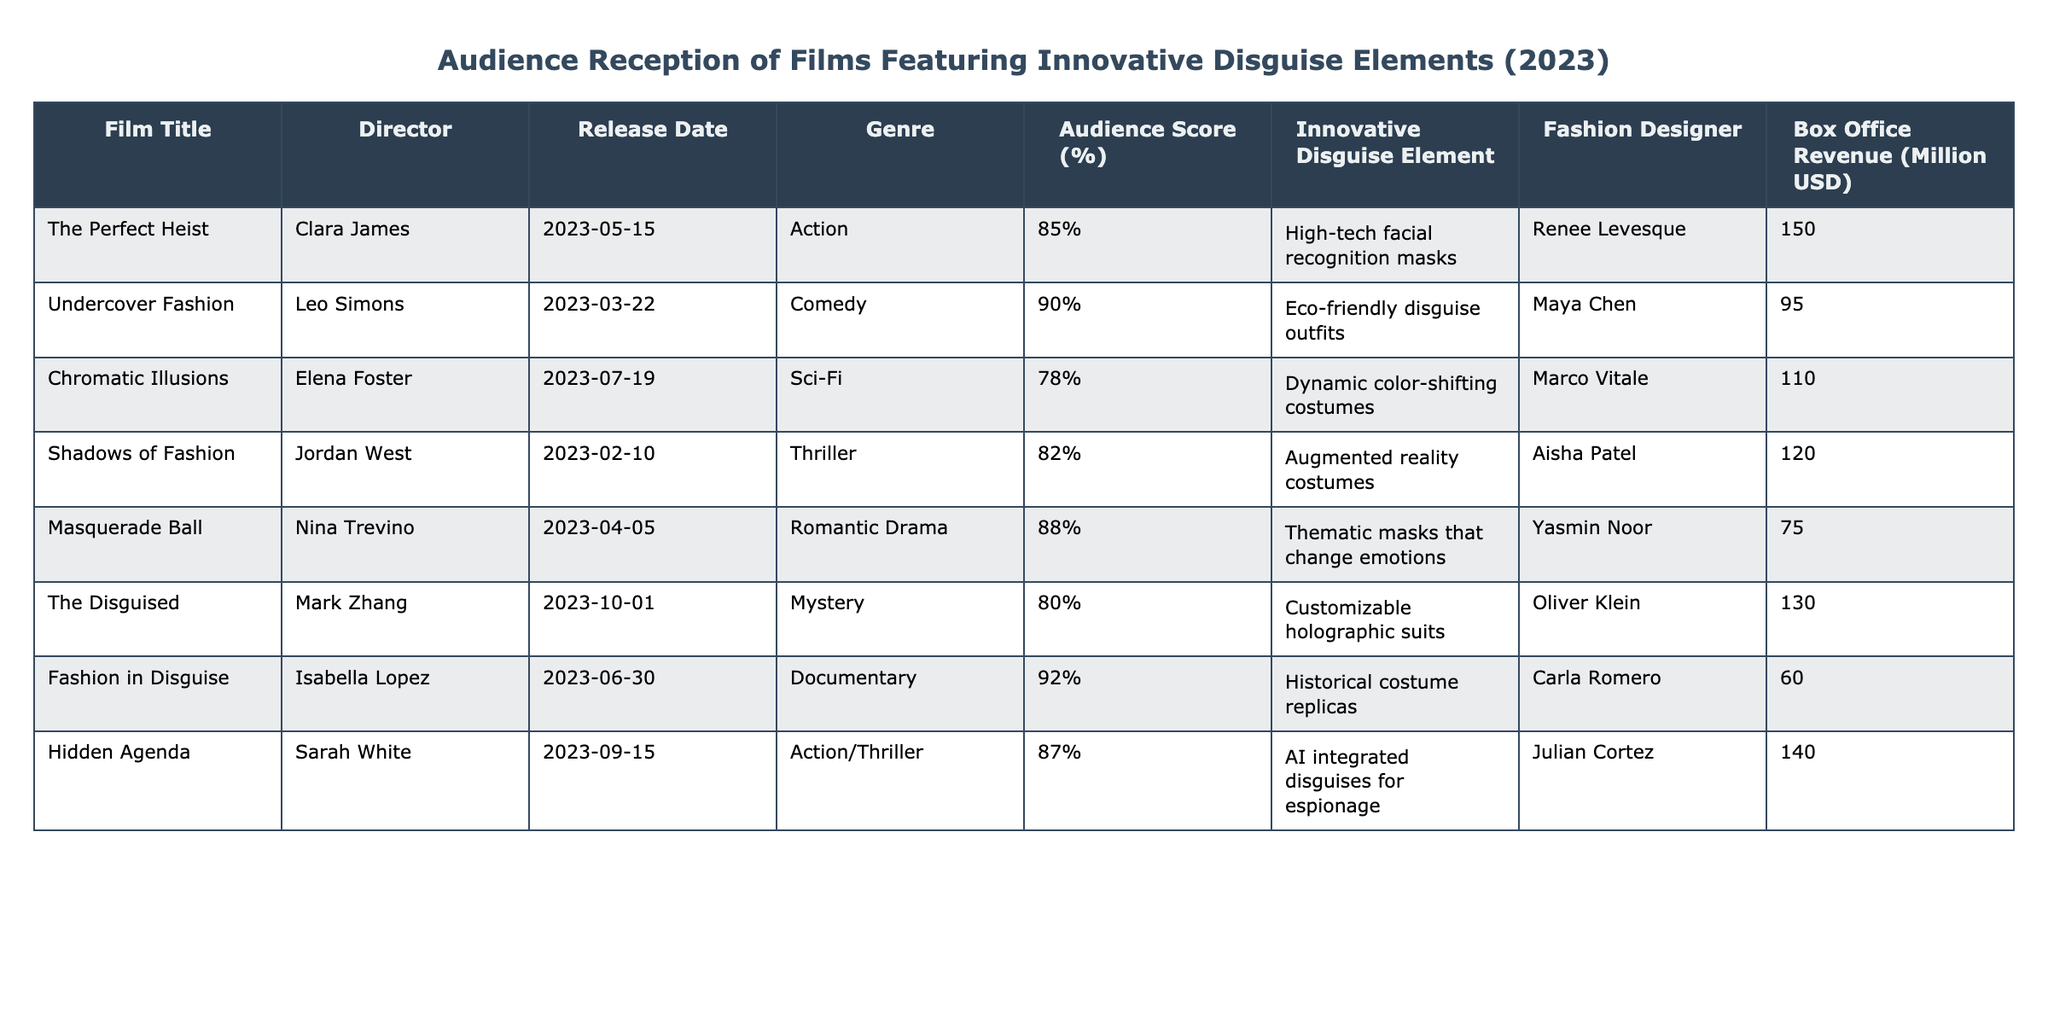What is the highest audience score percentage among the films listed? By looking at the "Audience Score (%)" column, I check for the maximum value, which is 92% from "Fashion in Disguise".
Answer: 92% Which film features eco-friendly disguise outfits? The film "Undercover Fashion" is listed with the innovative disguise element of eco-friendly disguise outfits.
Answer: Undercover Fashion What is the box office revenue for "Masquerade Ball"? The "Box Office Revenue (Million USD)" column shows that "Masquerade Ball" earned 75 million USD.
Answer: 75 Calculate the average audience score of the listed films. The scores are 85, 90, 78, 82, 88, 80, 92, and 87. Summing these scores gives 85 + 90 + 78 + 82 + 88 + 80 + 92 + 87 =  702. Dividing by the number of films (8) gives an average score of 702/8 = 87.75.
Answer: 87.75 Is it true that "Hidden Agenda" has a higher box office revenue than "Chromatic Illusions"? "Hidden Agenda" has a box office revenue of 140 million USD, while "Chromatic Illusions" has 110 million USD. Since 140 > 110, this statement is true.
Answer: True Which fashion designer worked on the film that features dynamic color-shifting costumes? Referring to the "Innovative Disguise Element" column for "Chromatic Illusions," it is noted that the fashion designer Marco Vitale worked on it.
Answer: Marco Vitale What is the total box office revenue of films in the Action genre? The films in the Action genre are "The Perfect Heist" (150), "Hidden Agenda" (140), and "Shadows of Fashion" (120). Adding these gives 150 + 140 + 120 = 410 million USD as the total box office revenue for the Action genre.
Answer: 410 Identify the film with the lowest audience score and its corresponding disguise element. The film with the lowest audience score of 78% is "Chromatic Illusions," which features the disguise element of dynamic color-shifting costumes.
Answer: Chromatic Illusions, dynamic color-shifting costumes How many films were directed by women based on this table? The films directed by women in the table are "Clara James" (The Perfect Heist), "Elena Foster" (Chromatic Illusions), "Nina Trevino" (Masquerade Ball), and "Isabella Lopez" (Fashion in Disguise), totaling four films.
Answer: 4 Which film received a score of 88% and what was its innovative disguise element? The film "Masquerade Ball" received an audience score of 88%, and its innovative disguise element is thematic masks that change emotions.
Answer: Masquerade Ball, thematic masks that change emotions 